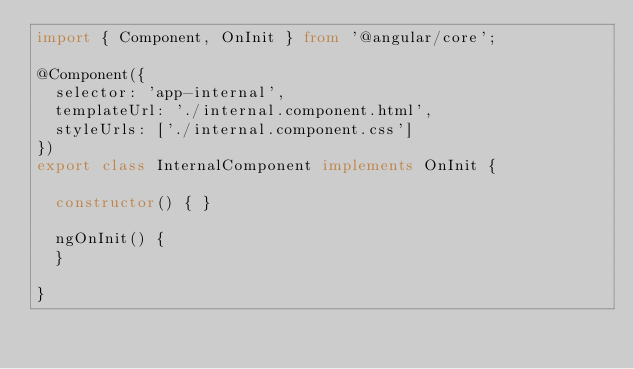Convert code to text. <code><loc_0><loc_0><loc_500><loc_500><_TypeScript_>import { Component, OnInit } from '@angular/core';

@Component({
  selector: 'app-internal',
  templateUrl: './internal.component.html',
  styleUrls: ['./internal.component.css']
})
export class InternalComponent implements OnInit {

  constructor() { }

  ngOnInit() {
  }

}
</code> 